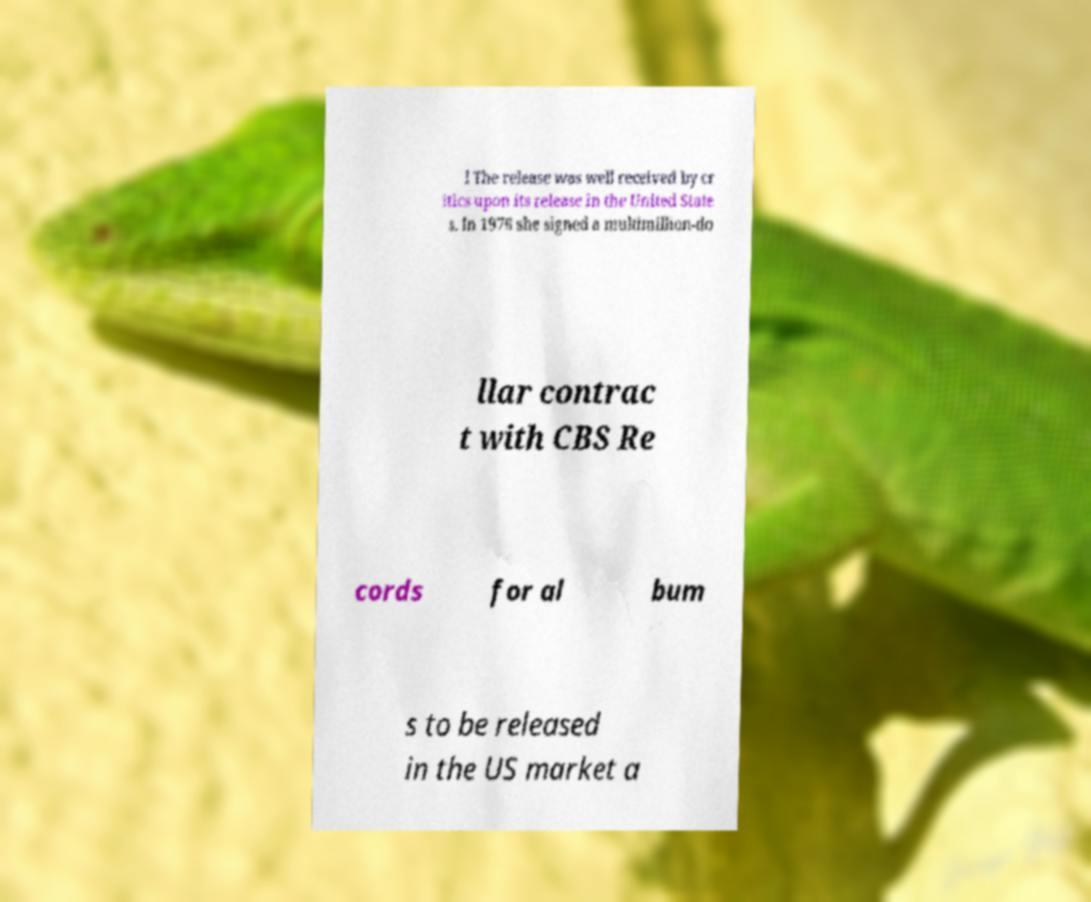Can you read and provide the text displayed in the image?This photo seems to have some interesting text. Can you extract and type it out for me? l The release was well received by cr itics upon its release in the United State s. In 1976 she signed a multimillion-do llar contrac t with CBS Re cords for al bum s to be released in the US market a 